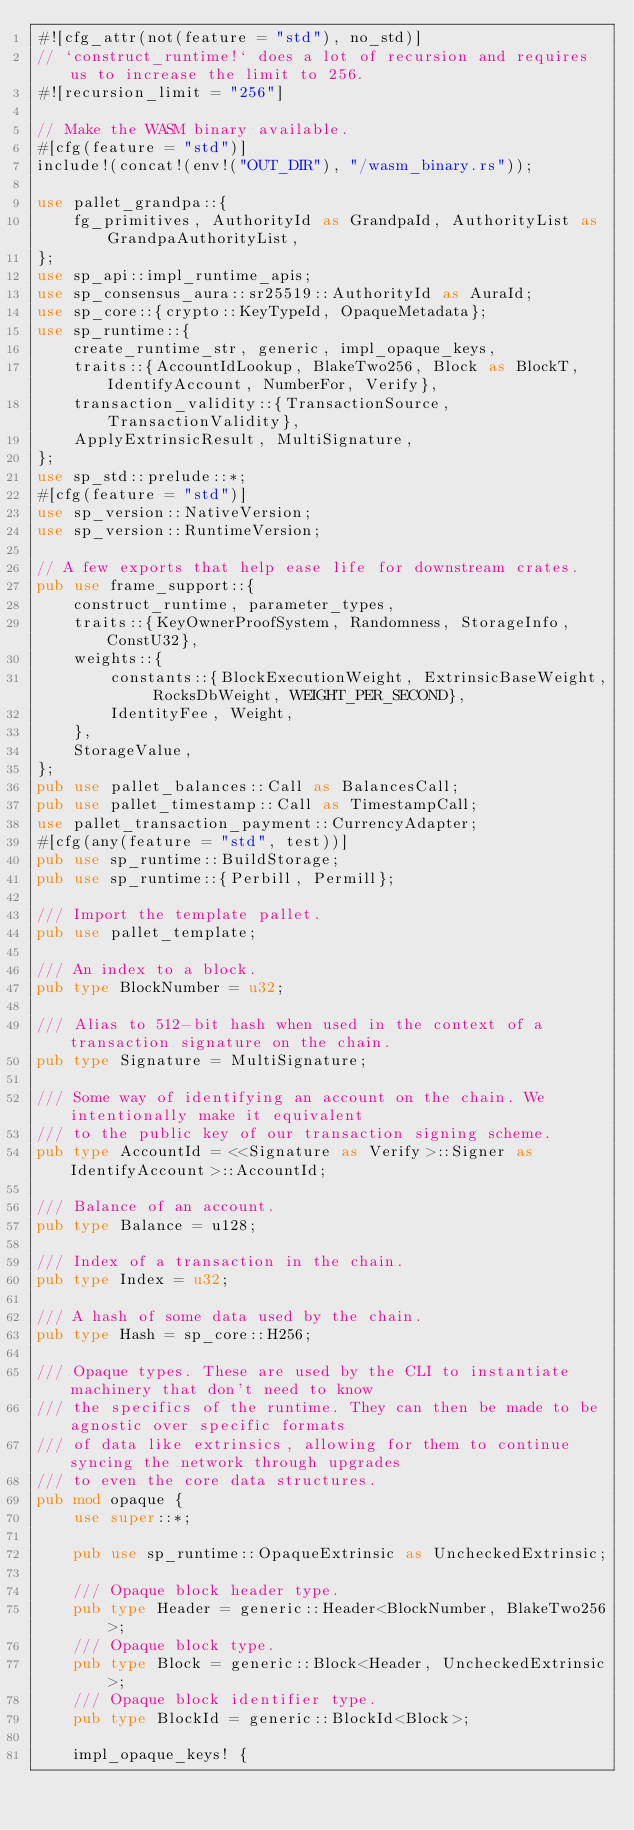<code> <loc_0><loc_0><loc_500><loc_500><_Rust_>#![cfg_attr(not(feature = "std"), no_std)]
// `construct_runtime!` does a lot of recursion and requires us to increase the limit to 256.
#![recursion_limit = "256"]

// Make the WASM binary available.
#[cfg(feature = "std")]
include!(concat!(env!("OUT_DIR"), "/wasm_binary.rs"));

use pallet_grandpa::{
	fg_primitives, AuthorityId as GrandpaId, AuthorityList as GrandpaAuthorityList,
};
use sp_api::impl_runtime_apis;
use sp_consensus_aura::sr25519::AuthorityId as AuraId;
use sp_core::{crypto::KeyTypeId, OpaqueMetadata};
use sp_runtime::{
	create_runtime_str, generic, impl_opaque_keys,
	traits::{AccountIdLookup, BlakeTwo256, Block as BlockT, IdentifyAccount, NumberFor, Verify},
	transaction_validity::{TransactionSource, TransactionValidity},
	ApplyExtrinsicResult, MultiSignature,
};
use sp_std::prelude::*;
#[cfg(feature = "std")]
use sp_version::NativeVersion;
use sp_version::RuntimeVersion;

// A few exports that help ease life for downstream crates.
pub use frame_support::{
	construct_runtime, parameter_types,
	traits::{KeyOwnerProofSystem, Randomness, StorageInfo, ConstU32},
	weights::{
		constants::{BlockExecutionWeight, ExtrinsicBaseWeight, RocksDbWeight, WEIGHT_PER_SECOND},
		IdentityFee, Weight,
	},
	StorageValue,
};
pub use pallet_balances::Call as BalancesCall;
pub use pallet_timestamp::Call as TimestampCall;
use pallet_transaction_payment::CurrencyAdapter;
#[cfg(any(feature = "std", test))]
pub use sp_runtime::BuildStorage;
pub use sp_runtime::{Perbill, Permill};

/// Import the template pallet.
pub use pallet_template;

/// An index to a block.
pub type BlockNumber = u32;

/// Alias to 512-bit hash when used in the context of a transaction signature on the chain.
pub type Signature = MultiSignature;

/// Some way of identifying an account on the chain. We intentionally make it equivalent
/// to the public key of our transaction signing scheme.
pub type AccountId = <<Signature as Verify>::Signer as IdentifyAccount>::AccountId;

/// Balance of an account.
pub type Balance = u128;

/// Index of a transaction in the chain.
pub type Index = u32;

/// A hash of some data used by the chain.
pub type Hash = sp_core::H256;

/// Opaque types. These are used by the CLI to instantiate machinery that don't need to know
/// the specifics of the runtime. They can then be made to be agnostic over specific formats
/// of data like extrinsics, allowing for them to continue syncing the network through upgrades
/// to even the core data structures.
pub mod opaque {
	use super::*;

	pub use sp_runtime::OpaqueExtrinsic as UncheckedExtrinsic;

	/// Opaque block header type.
	pub type Header = generic::Header<BlockNumber, BlakeTwo256>;
	/// Opaque block type.
	pub type Block = generic::Block<Header, UncheckedExtrinsic>;
	/// Opaque block identifier type.
	pub type BlockId = generic::BlockId<Block>;

	impl_opaque_keys! {</code> 